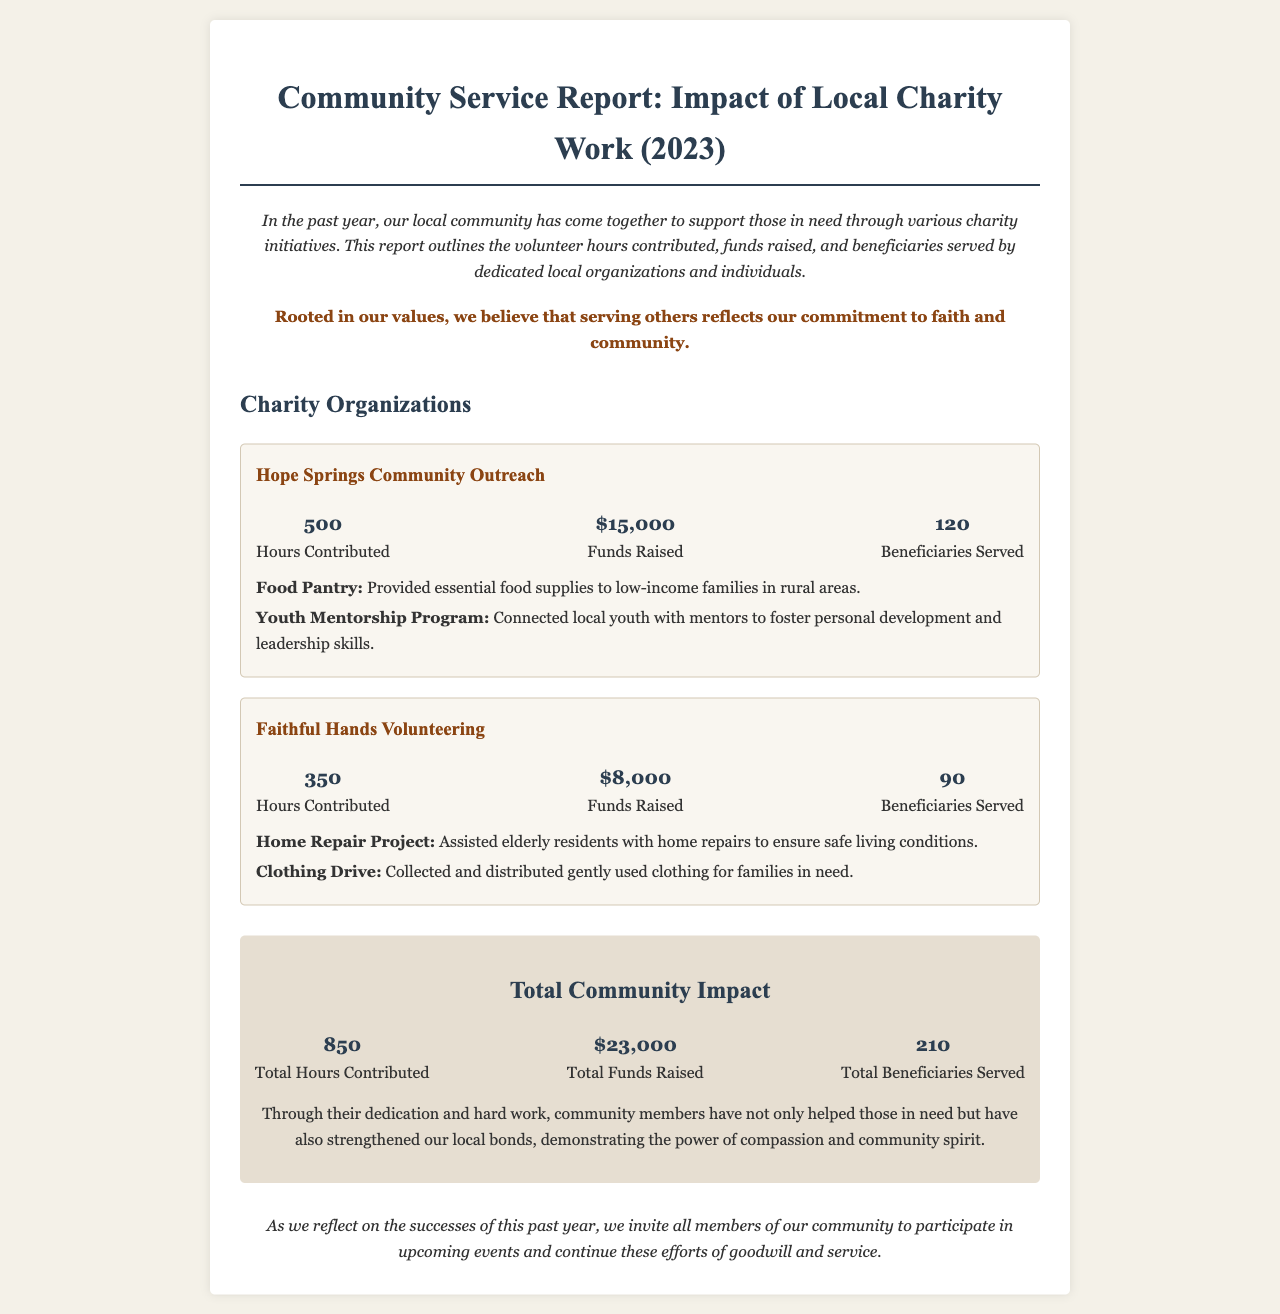What is the total hours contributed? The total hours contributed are displayed in the section titled "Total Community Impact" where it shows the number of hours contributed by all organizations.
Answer: 850 How much money was raised by Hope Springs Community Outreach? The funds raised by Hope Springs Community Outreach are listed under that charity organization's stats section.
Answer: $15,000 How many beneficiaries were served by Faithful Hands Volunteering? The number of beneficiaries served by Faithful Hands Volunteering is shown in the stats section of that charity organization.
Answer: 90 What program did Hope Springs Community Outreach run that involves food supplies? The program related to food supplies is mentioned among the programs of Hope Springs Community Outreach.
Answer: Food Pantry What is the total amount of funds raised by both organizations? The total funds raised are calculated from each organization's contributions and presented in the "Total Community Impact" section.
Answer: $23,000 Which organization assisted elderly residents with home repairs? This organization is detailed in the programs section of Faithful Hands Volunteering.
Answer: Faithful Hands Volunteering What is the primary focus of the Youth Mentorship Program? This program is described in Hope Springs Community Outreach's programs, emphasizing personal development and skills.
Answer: Personal development and leadership skills How many total beneficiaries were served across both organizations? The total beneficiaries served is presented in the "Total Community Impact" section summarizing the outreach.
Answer: 210 What is the inspirational message in this community service report? The report highlights the belief that serving others reflects a commitment to faith and community, which is stated at the beginning of the document.
Answer: Serving others reflects our commitment to faith and community 